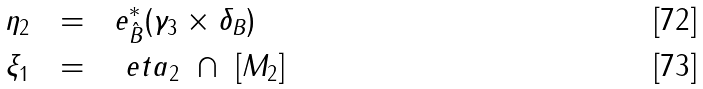<formula> <loc_0><loc_0><loc_500><loc_500>\eta _ { 2 } \ \ & = \ \ e _ { \hat { B } } ^ { * } ( \gamma _ { 3 } \times \delta _ { B } ) \\ \xi _ { 1 } \ \ & = \ \ \ e t a _ { 2 } \ \cap \ \left [ M _ { 2 } \right ]</formula> 